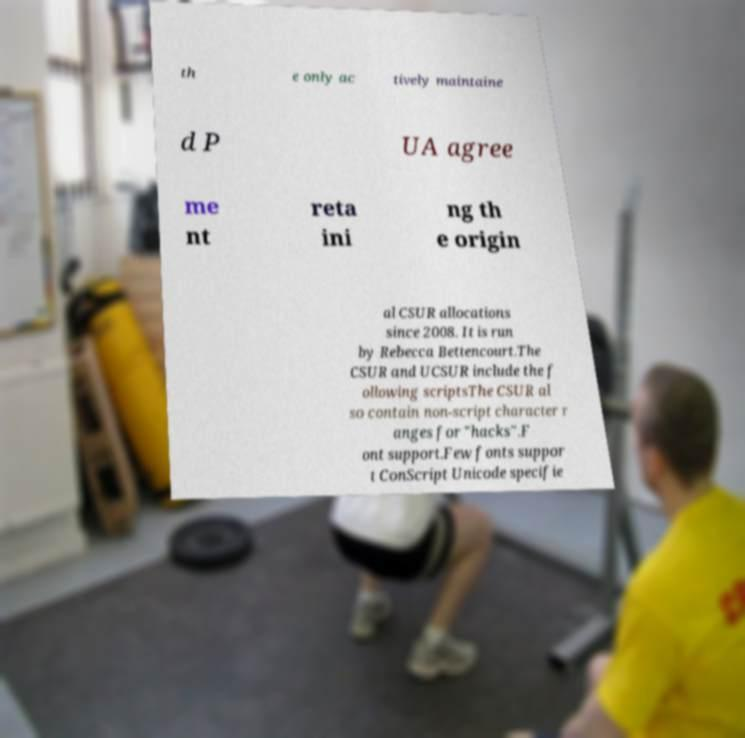Please identify and transcribe the text found in this image. th e only ac tively maintaine d P UA agree me nt reta ini ng th e origin al CSUR allocations since 2008. It is run by Rebecca Bettencourt.The CSUR and UCSUR include the f ollowing scriptsThe CSUR al so contain non-script character r anges for "hacks".F ont support.Few fonts suppor t ConScript Unicode specifie 